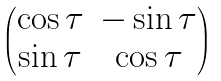<formula> <loc_0><loc_0><loc_500><loc_500>\begin{pmatrix} \cos \tau & - \sin \tau \\ \sin \tau & \cos \tau \end{pmatrix}</formula> 